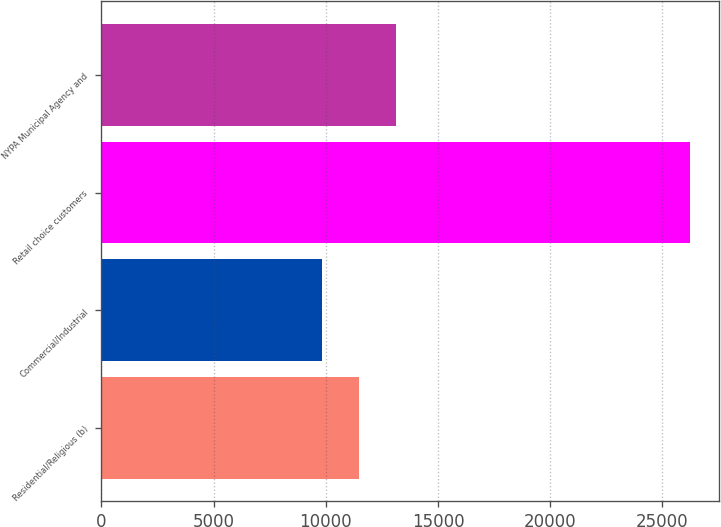<chart> <loc_0><loc_0><loc_500><loc_500><bar_chart><fcel>Residential/Religious (b)<fcel>Commercial/Industrial<fcel>Retail choice customers<fcel>NYPA Municipal Agency and<nl><fcel>11472.7<fcel>9834<fcel>26221<fcel>13111.4<nl></chart> 